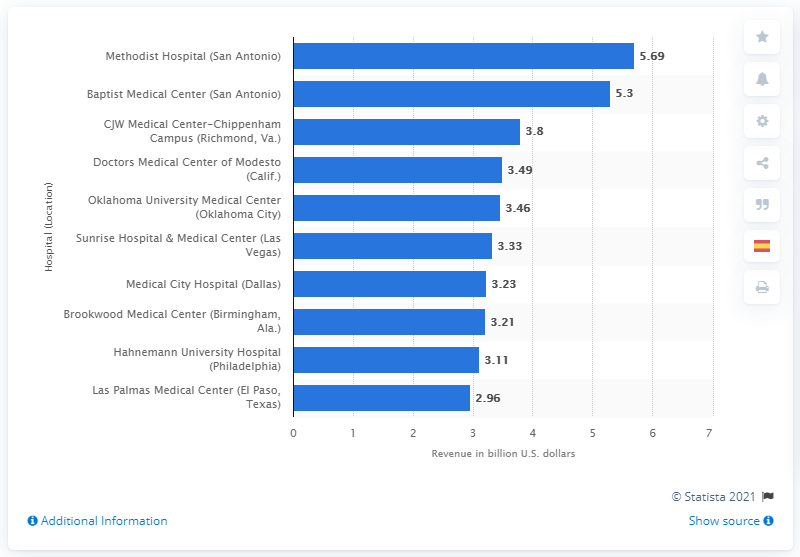Identify some key points in this picture. The gross revenue of the Methodist Hospital in 2013 was $5.69 million. 